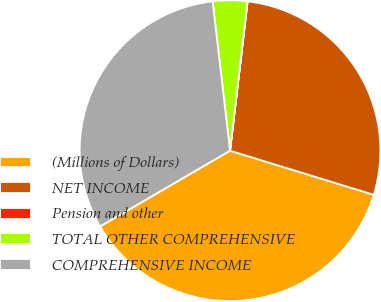<chart> <loc_0><loc_0><loc_500><loc_500><pie_chart><fcel>(Millions of Dollars)<fcel>NET INCOME<fcel>Pension and other<fcel>TOTAL OTHER COMPREHENSIVE<fcel>COMPREHENSIVE INCOME<nl><fcel>36.86%<fcel>27.87%<fcel>0.02%<fcel>3.7%<fcel>31.55%<nl></chart> 